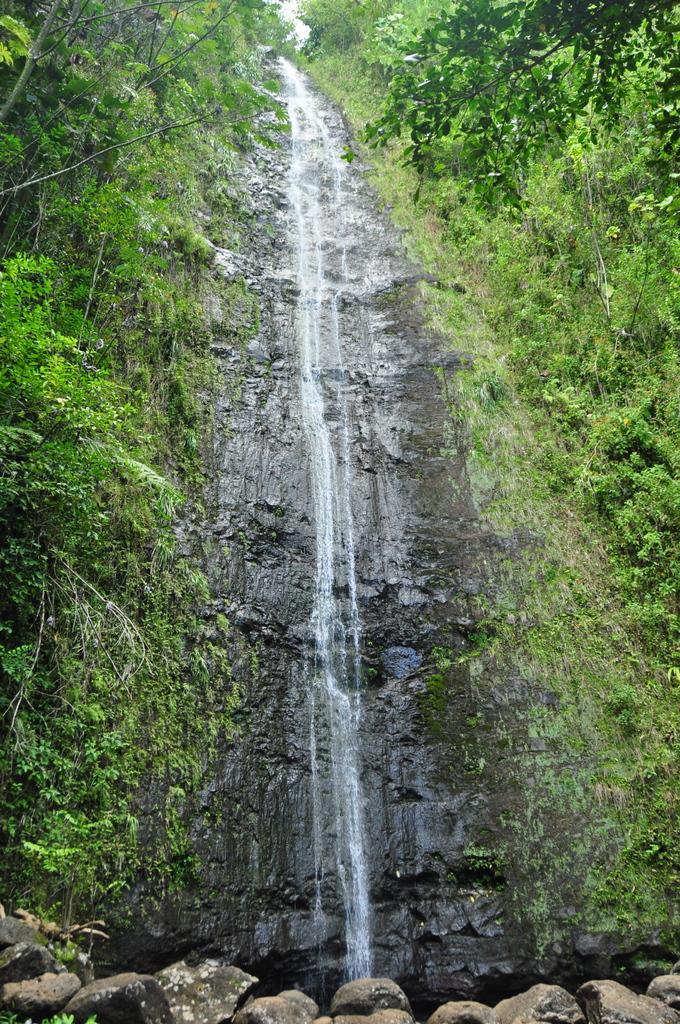How would you summarize this image in a sentence or two? In this image we can see waterfall. Also there are rocks. On the sides there are trees and plants. 